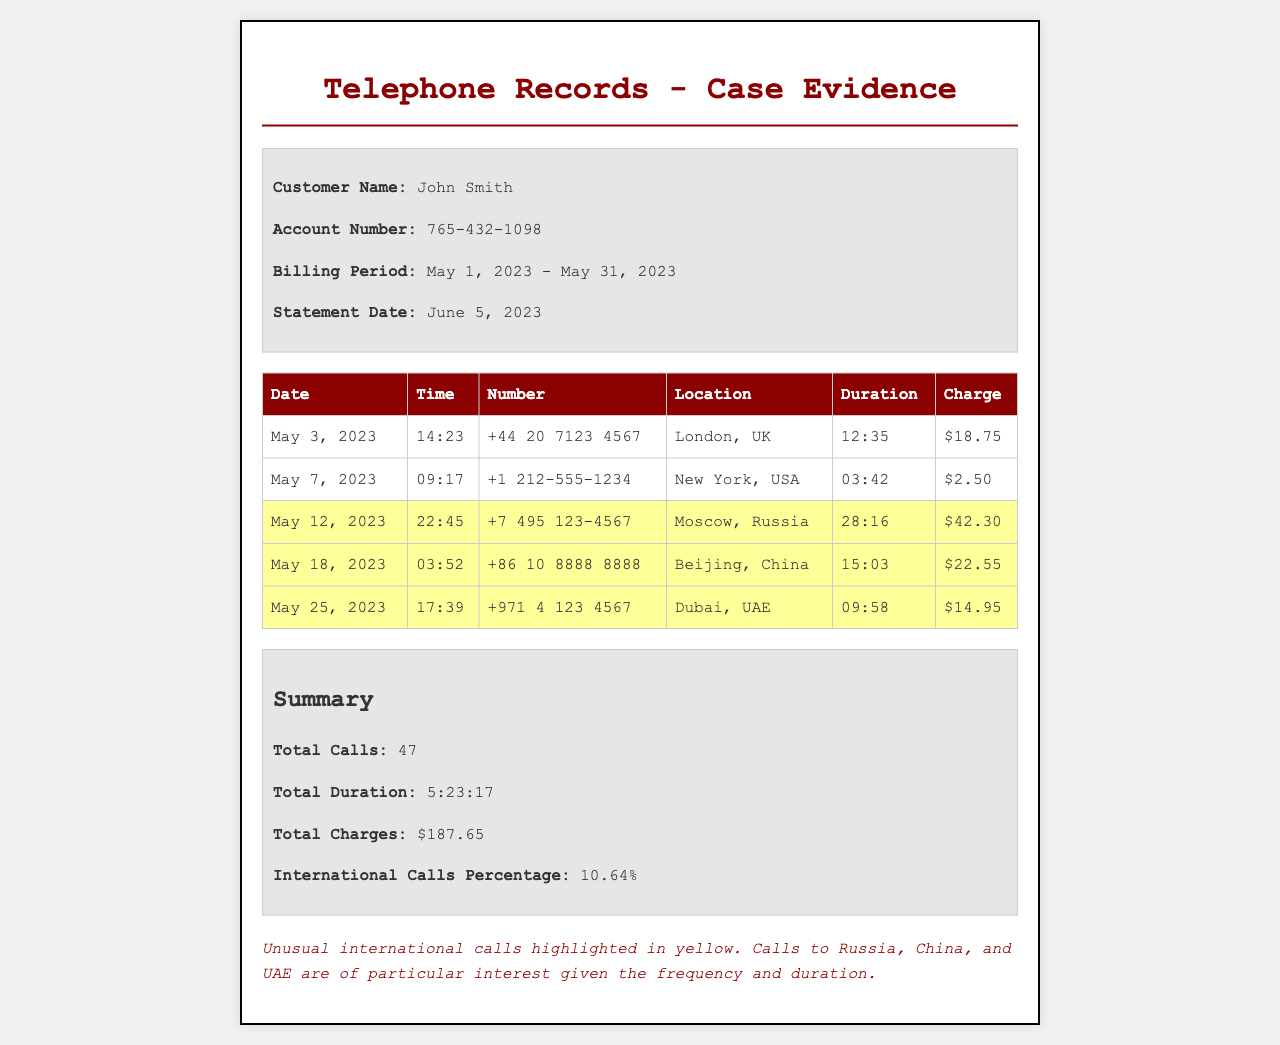what is the customer name? The customer name is specified at the top of the document in the header section.
Answer: John Smith what is the account number? The account number is listed in the document's header section under customer details.
Answer: 765-432-1098 how many total calls were made? The total number of calls is provided in the summary section of the document.
Answer: 47 what is the charge for the call made to Beijing, China? The charge for that specific call is detailed in the table where international calls are listed.
Answer: $22.55 which country has the call with the longest duration? The duration of calls is provided in the table, and reasoning through the durations leads to the country with the longest.
Answer: Moscow, Russia what was the date of the call with the highest charge? The charges for the calls are listed, and the highest charge can be identified easily from the table.
Answer: May 12, 2023 what is the total duration of all calls? The total duration is summarized in the summary section.
Answer: 5:23:17 how many international calls were highlighted? The highlighted calls indicate international calls, and counting them gives the answer.
Answer: 3 what is the percentage of international calls? The international calls percentage is mentioned in the summary section of the document.
Answer: 10.64% 